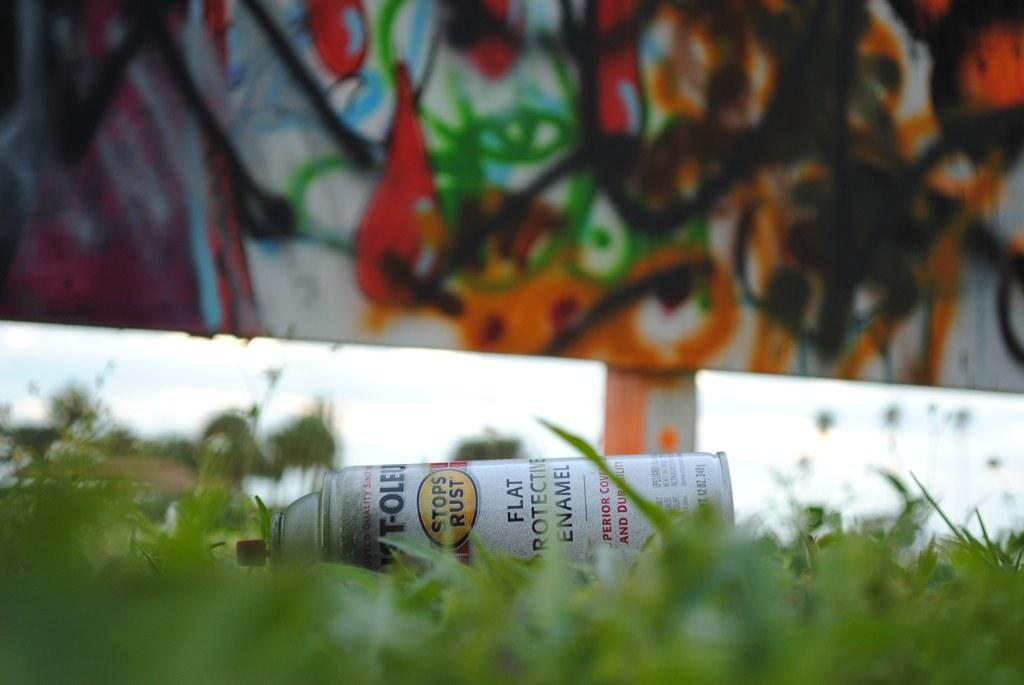Provide a one-sentence caption for the provided image. Can of flat protector enamel laying in the grass. 